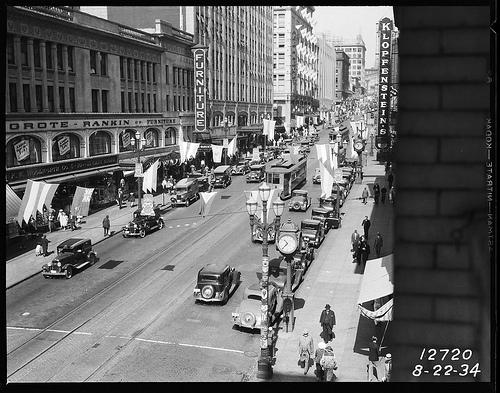What is in the street?

Choices:
A) cows
B) cats
C) cars
D) tank cars 